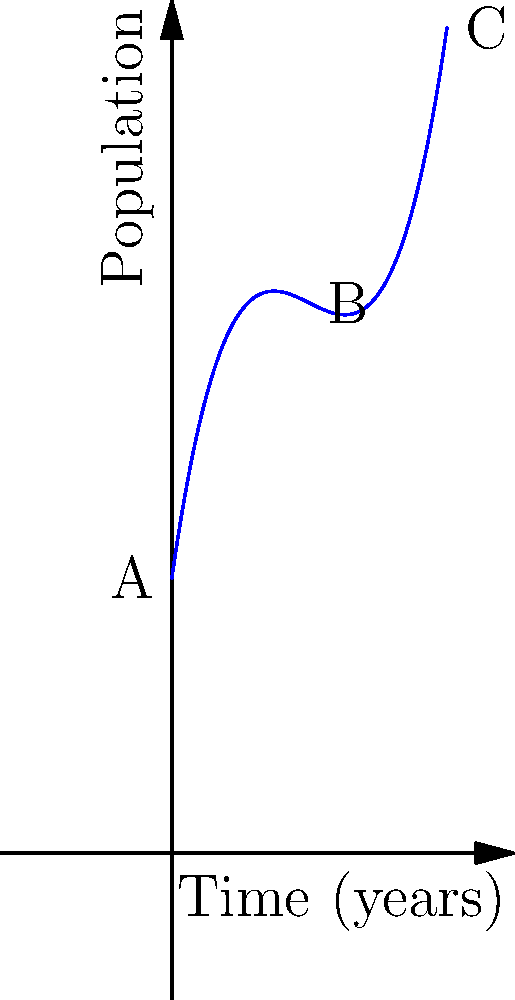As an environmental historian studying an endangered species of tree in a protected forest, you've come across a population model represented by the cubic polynomial $P(t) = 0.1t^3 - 1.5t^2 + 7t + 10$, where $P$ is the population and $t$ is time in years. Based on the graph, at which point (A, B, or C) does the population growth rate appear to be the highest, and what might this suggest about human-nature interactions in the area? To determine the point of highest population growth rate, we need to analyze the slope of the curve at each point:

1. Point A (t = 0): The curve starts with a positive slope, indicating growth.

2. Point B (t = 5): The slope is steeper than at point A, suggesting a higher growth rate.

3. Point C (t = 10): The slope is the steepest, indicating the highest growth rate.

The growth rate is represented by the derivative of the population function:

$P'(t) = 0.3t^2 - 3t + 7$

As t increases, the quadratic term $0.3t^2$ becomes more dominant, leading to an increasing growth rate.

From an environmental historian's perspective, this pattern suggests:

1. Initial slow growth (Point A): Possibly due to the species' endangered status and limited conservation efforts.

2. Accelerating growth (Point B): Likely reflects successful conservation measures and increased public awareness.

3. Rapid growth (Point C): Indicates highly effective protection and possibly favorable environmental conditions.

This model suggests a positive human-nature interaction where conservation efforts have successfully promoted the species' recovery, potentially through habitat protection, breeding programs, or reduced human interference in the forest ecosystem.
Answer: Point C; suggests successful conservation efforts and positive human-nature interactions. 